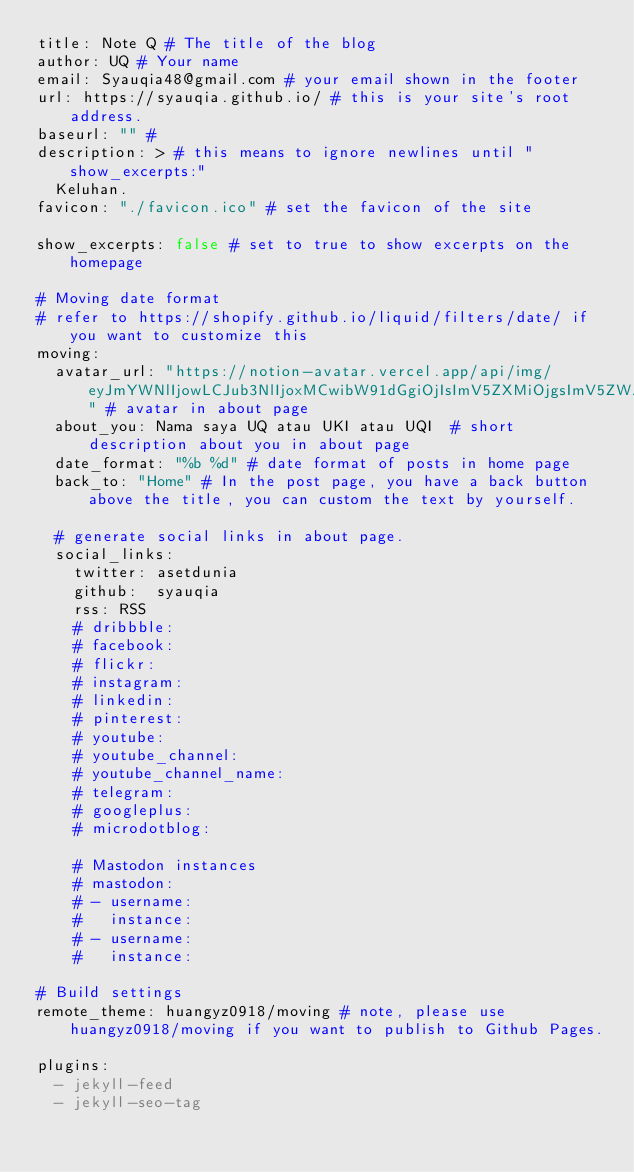<code> <loc_0><loc_0><loc_500><loc_500><_YAML_>title: Note Q # The title of the blog
author: UQ # Your name 
email: Syauqia48@gmail.com # your email shown in the footer
url: https://syauqia.github.io/ # this is your site's root address.
baseurl: "" #
description: > # this means to ignore newlines until "show_excerpts:"
  Keluhan.
favicon: "./favicon.ico" # set the favicon of the site 

show_excerpts: false # set to true to show excerpts on the homepage
  
# Moving date format
# refer to https://shopify.github.io/liquid/filters/date/ if you want to customize this
moving:
  avatar_url: "https://notion-avatar.vercel.app/api/img/eyJmYWNlIjowLCJub3NlIjoxMCwibW91dGgiOjIsImV5ZXMiOjgsImV5ZWJyb3dzIjowLCJnbGFzc2VzIjozLCJoYWlyIjoxNiwiYWNjZXNzb3JpZXMiOjAsImRldGFpbHMiOjAsImJlYXJkIjowLCJmbGlwIjowLCJjb2xvciI6InJnYmEoMjU1LCAwLCAwLCAwKSIsInNoYXBlIjoibm9uZSJ9" # avatar in about page
  about_you: Nama saya UQ atau UKI atau UQI  # short description about you in about page
  date_format: "%b %d" # date format of posts in home page
  back_to: "Home" # In the post page, you have a back button above the title, you can custom the text by yourself.

  # generate social links in about page.
  social_links:
    twitter: asetdunia
    github:  syauqia
    rss: RSS
    # dribbble: 
    # facebook:
    # flickr:   
    # instagram: 
    # linkedin:
    # pinterest: 
    # youtube: 
    # youtube_channel: 
    # youtube_channel_name: 
    # telegram: 
    # googleplus: 
    # microdotblog: 

    # Mastodon instances
    # mastodon:
    # - username: 
    #   instance: 
    # - username: 
    #   instance: 

# Build settings
remote_theme: huangyz0918/moving # note, please use huangyz0918/moving if you want to publish to Github Pages.

plugins:
  - jekyll-feed
  - jekyll-seo-tag
</code> 